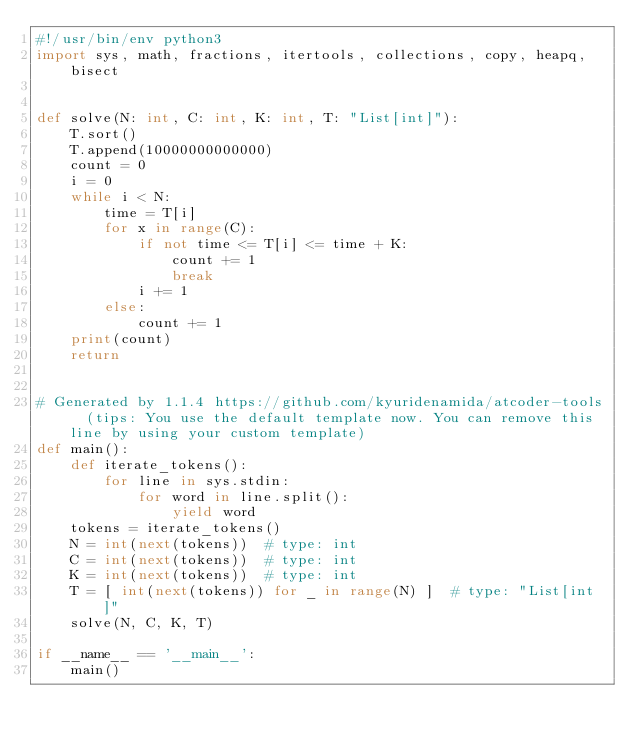<code> <loc_0><loc_0><loc_500><loc_500><_Python_>#!/usr/bin/env python3
import sys, math, fractions, itertools, collections, copy, heapq, bisect


def solve(N: int, C: int, K: int, T: "List[int]"):
    T.sort()
    T.append(10000000000000)
    count = 0
    i = 0
    while i < N:
        time = T[i]
        for x in range(C):
            if not time <= T[i] <= time + K:
                count += 1
                break
            i += 1
        else:
            count += 1
    print(count)
    return


# Generated by 1.1.4 https://github.com/kyuridenamida/atcoder-tools  (tips: You use the default template now. You can remove this line by using your custom template)
def main():
    def iterate_tokens():
        for line in sys.stdin:
            for word in line.split():
                yield word
    tokens = iterate_tokens()
    N = int(next(tokens))  # type: int
    C = int(next(tokens))  # type: int
    K = int(next(tokens))  # type: int
    T = [ int(next(tokens)) for _ in range(N) ]  # type: "List[int]"
    solve(N, C, K, T)

if __name__ == '__main__':
    main()
</code> 